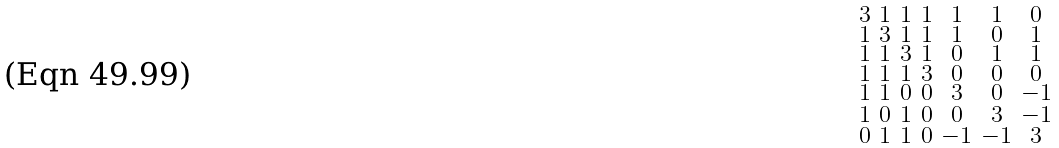Convert formula to latex. <formula><loc_0><loc_0><loc_500><loc_500>\begin{smallmatrix} 3 & 1 & 1 & 1 & 1 & 1 & 0 \\ 1 & 3 & 1 & 1 & 1 & 0 & 1 \\ 1 & 1 & 3 & 1 & 0 & 1 & 1 \\ 1 & 1 & 1 & 3 & 0 & 0 & 0 \\ 1 & 1 & 0 & 0 & 3 & 0 & - 1 \\ 1 & 0 & 1 & 0 & 0 & 3 & - 1 \\ 0 & 1 & 1 & 0 & - 1 & - 1 & 3 \end{smallmatrix}</formula> 